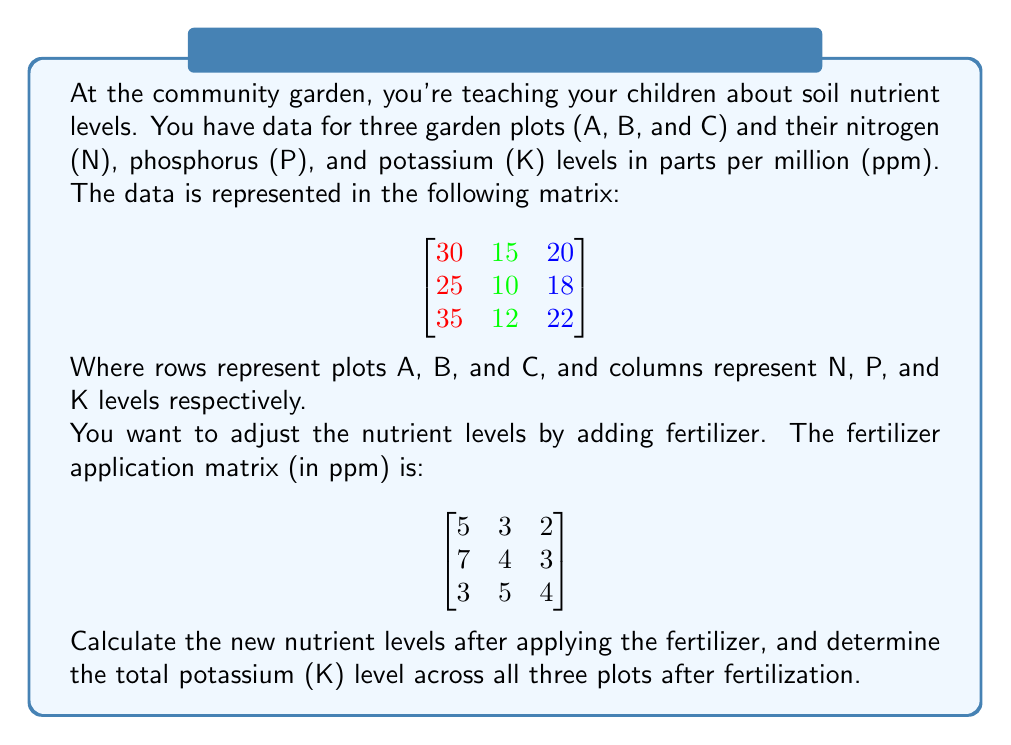Show me your answer to this math problem. Let's approach this step-by-step:

1) First, we need to add the initial nutrient matrix to the fertilizer application matrix. In matrix addition, we add corresponding elements:

   $$
   \begin{bmatrix}
   30 & 15 & 20 \\
   25 & 10 & 18 \\
   35 & 12 & 22
   \end{bmatrix}
   +
   \begin{bmatrix}
   5 & 3 & 2 \\
   7 & 4 & 3 \\
   3 & 5 & 4
   \end{bmatrix}
   =
   \begin{bmatrix}
   35 & 18 & 22 \\
   32 & 14 & 21 \\
   38 & 17 & 26
   \end{bmatrix}
   $$

2) This new matrix represents the nutrient levels after fertilization.

3) To find the total potassium (K) level, we need to sum the elements in the third column of the resulting matrix:

   $22 + 21 + 26 = 69$

Therefore, the total potassium level across all three plots after fertilization is 69 ppm.
Answer: 69 ppm 